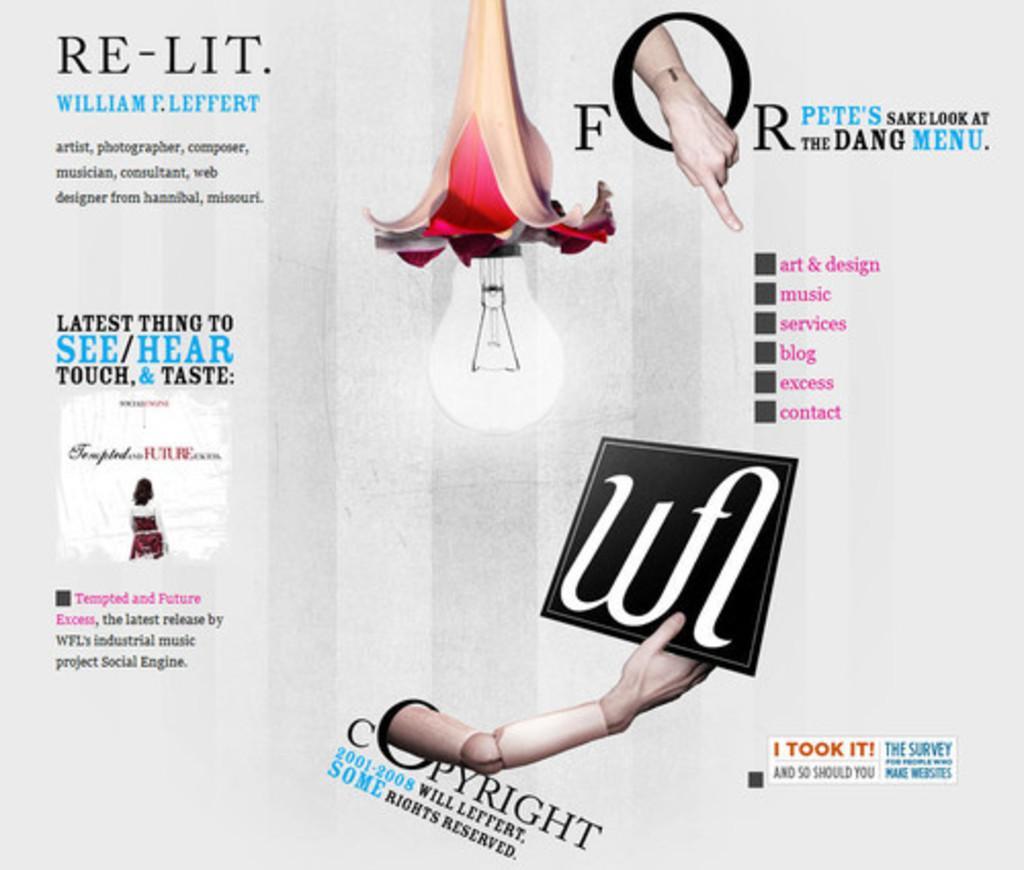Could you give a brief overview of what you see in this image? In this image we can see an advertisement. 